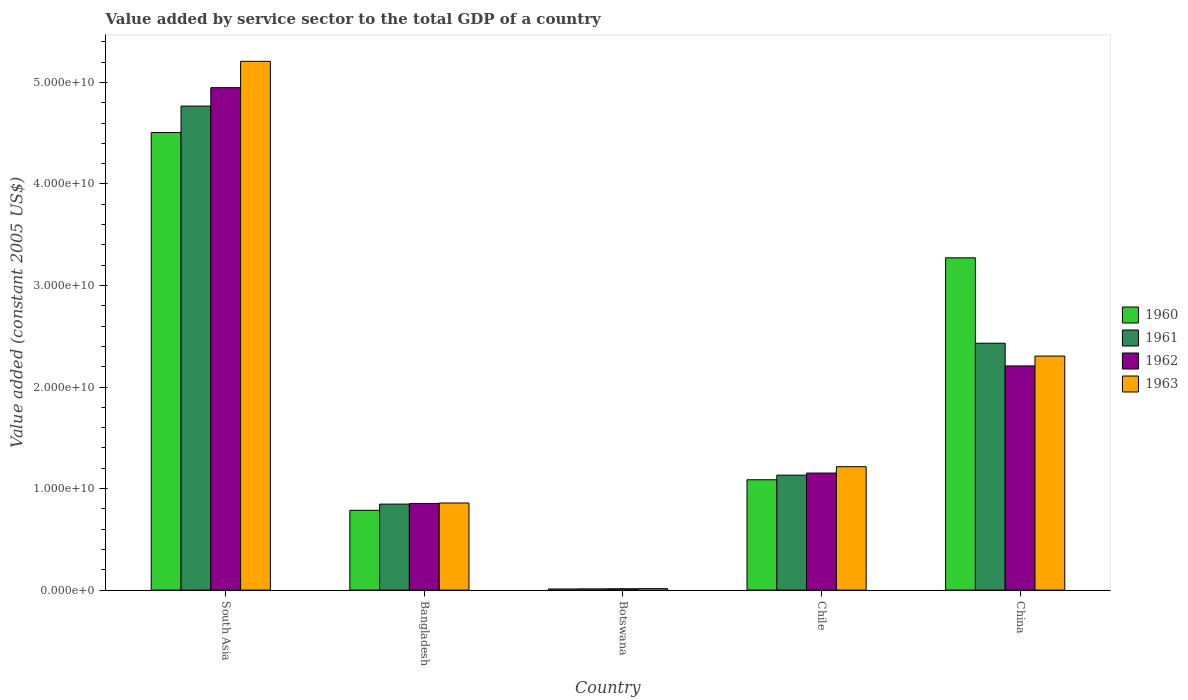Are the number of bars per tick equal to the number of legend labels?
Provide a short and direct response. Yes. Are the number of bars on each tick of the X-axis equal?
Your answer should be very brief. Yes. What is the label of the 2nd group of bars from the left?
Your answer should be very brief. Bangladesh. In how many cases, is the number of bars for a given country not equal to the number of legend labels?
Make the answer very short. 0. What is the value added by service sector in 1963 in Chile?
Your answer should be very brief. 1.22e+1. Across all countries, what is the maximum value added by service sector in 1961?
Your answer should be compact. 4.77e+1. Across all countries, what is the minimum value added by service sector in 1961?
Provide a short and direct response. 1.22e+08. In which country was the value added by service sector in 1962 minimum?
Your response must be concise. Botswana. What is the total value added by service sector in 1963 in the graph?
Offer a very short reply. 9.60e+1. What is the difference between the value added by service sector in 1961 in China and that in South Asia?
Provide a succinct answer. -2.34e+1. What is the difference between the value added by service sector in 1962 in Botswana and the value added by service sector in 1963 in Bangladesh?
Provide a short and direct response. -8.44e+09. What is the average value added by service sector in 1963 per country?
Ensure brevity in your answer.  1.92e+1. What is the difference between the value added by service sector of/in 1961 and value added by service sector of/in 1962 in Bangladesh?
Offer a terse response. -5.33e+07. What is the ratio of the value added by service sector in 1961 in Chile to that in China?
Offer a very short reply. 0.47. What is the difference between the highest and the second highest value added by service sector in 1960?
Your answer should be very brief. 1.23e+1. What is the difference between the highest and the lowest value added by service sector in 1963?
Your answer should be compact. 5.19e+1. In how many countries, is the value added by service sector in 1960 greater than the average value added by service sector in 1960 taken over all countries?
Provide a succinct answer. 2. Is it the case that in every country, the sum of the value added by service sector in 1961 and value added by service sector in 1963 is greater than the sum of value added by service sector in 1962 and value added by service sector in 1960?
Your answer should be very brief. No. Are all the bars in the graph horizontal?
Your answer should be very brief. No. What is the difference between two consecutive major ticks on the Y-axis?
Make the answer very short. 1.00e+1. Are the values on the major ticks of Y-axis written in scientific E-notation?
Ensure brevity in your answer.  Yes. Does the graph contain any zero values?
Your answer should be very brief. No. Does the graph contain grids?
Give a very brief answer. No. How many legend labels are there?
Your answer should be very brief. 4. How are the legend labels stacked?
Offer a very short reply. Vertical. What is the title of the graph?
Your answer should be compact. Value added by service sector to the total GDP of a country. What is the label or title of the Y-axis?
Offer a terse response. Value added (constant 2005 US$). What is the Value added (constant 2005 US$) in 1960 in South Asia?
Provide a succinct answer. 4.51e+1. What is the Value added (constant 2005 US$) of 1961 in South Asia?
Offer a very short reply. 4.77e+1. What is the Value added (constant 2005 US$) in 1962 in South Asia?
Provide a short and direct response. 4.95e+1. What is the Value added (constant 2005 US$) in 1963 in South Asia?
Your response must be concise. 5.21e+1. What is the Value added (constant 2005 US$) in 1960 in Bangladesh?
Offer a terse response. 7.86e+09. What is the Value added (constant 2005 US$) in 1961 in Bangladesh?
Give a very brief answer. 8.47e+09. What is the Value added (constant 2005 US$) of 1962 in Bangladesh?
Keep it short and to the point. 8.52e+09. What is the Value added (constant 2005 US$) of 1963 in Bangladesh?
Keep it short and to the point. 8.58e+09. What is the Value added (constant 2005 US$) of 1960 in Botswana?
Provide a succinct answer. 1.11e+08. What is the Value added (constant 2005 US$) in 1961 in Botswana?
Your response must be concise. 1.22e+08. What is the Value added (constant 2005 US$) of 1962 in Botswana?
Your answer should be very brief. 1.32e+08. What is the Value added (constant 2005 US$) in 1963 in Botswana?
Offer a very short reply. 1.45e+08. What is the Value added (constant 2005 US$) in 1960 in Chile?
Give a very brief answer. 1.09e+1. What is the Value added (constant 2005 US$) of 1961 in Chile?
Ensure brevity in your answer.  1.13e+1. What is the Value added (constant 2005 US$) of 1962 in Chile?
Ensure brevity in your answer.  1.15e+1. What is the Value added (constant 2005 US$) of 1963 in Chile?
Provide a short and direct response. 1.22e+1. What is the Value added (constant 2005 US$) in 1960 in China?
Offer a terse response. 3.27e+1. What is the Value added (constant 2005 US$) of 1961 in China?
Provide a succinct answer. 2.43e+1. What is the Value added (constant 2005 US$) of 1962 in China?
Provide a short and direct response. 2.21e+1. What is the Value added (constant 2005 US$) in 1963 in China?
Offer a terse response. 2.30e+1. Across all countries, what is the maximum Value added (constant 2005 US$) of 1960?
Your answer should be compact. 4.51e+1. Across all countries, what is the maximum Value added (constant 2005 US$) in 1961?
Make the answer very short. 4.77e+1. Across all countries, what is the maximum Value added (constant 2005 US$) of 1962?
Make the answer very short. 4.95e+1. Across all countries, what is the maximum Value added (constant 2005 US$) of 1963?
Provide a succinct answer. 5.21e+1. Across all countries, what is the minimum Value added (constant 2005 US$) of 1960?
Provide a succinct answer. 1.11e+08. Across all countries, what is the minimum Value added (constant 2005 US$) in 1961?
Provide a short and direct response. 1.22e+08. Across all countries, what is the minimum Value added (constant 2005 US$) of 1962?
Ensure brevity in your answer.  1.32e+08. Across all countries, what is the minimum Value added (constant 2005 US$) in 1963?
Provide a succinct answer. 1.45e+08. What is the total Value added (constant 2005 US$) in 1960 in the graph?
Keep it short and to the point. 9.66e+1. What is the total Value added (constant 2005 US$) of 1961 in the graph?
Offer a terse response. 9.19e+1. What is the total Value added (constant 2005 US$) of 1962 in the graph?
Your response must be concise. 9.17e+1. What is the total Value added (constant 2005 US$) of 1963 in the graph?
Provide a short and direct response. 9.60e+1. What is the difference between the Value added (constant 2005 US$) in 1960 in South Asia and that in Bangladesh?
Give a very brief answer. 3.72e+1. What is the difference between the Value added (constant 2005 US$) of 1961 in South Asia and that in Bangladesh?
Your response must be concise. 3.92e+1. What is the difference between the Value added (constant 2005 US$) in 1962 in South Asia and that in Bangladesh?
Provide a short and direct response. 4.10e+1. What is the difference between the Value added (constant 2005 US$) in 1963 in South Asia and that in Bangladesh?
Make the answer very short. 4.35e+1. What is the difference between the Value added (constant 2005 US$) of 1960 in South Asia and that in Botswana?
Provide a succinct answer. 4.50e+1. What is the difference between the Value added (constant 2005 US$) of 1961 in South Asia and that in Botswana?
Offer a very short reply. 4.75e+1. What is the difference between the Value added (constant 2005 US$) of 1962 in South Asia and that in Botswana?
Make the answer very short. 4.93e+1. What is the difference between the Value added (constant 2005 US$) in 1963 in South Asia and that in Botswana?
Offer a terse response. 5.19e+1. What is the difference between the Value added (constant 2005 US$) of 1960 in South Asia and that in Chile?
Your response must be concise. 3.42e+1. What is the difference between the Value added (constant 2005 US$) of 1961 in South Asia and that in Chile?
Keep it short and to the point. 3.63e+1. What is the difference between the Value added (constant 2005 US$) of 1962 in South Asia and that in Chile?
Provide a succinct answer. 3.80e+1. What is the difference between the Value added (constant 2005 US$) of 1963 in South Asia and that in Chile?
Keep it short and to the point. 3.99e+1. What is the difference between the Value added (constant 2005 US$) of 1960 in South Asia and that in China?
Your answer should be very brief. 1.23e+1. What is the difference between the Value added (constant 2005 US$) in 1961 in South Asia and that in China?
Provide a succinct answer. 2.34e+1. What is the difference between the Value added (constant 2005 US$) of 1962 in South Asia and that in China?
Make the answer very short. 2.74e+1. What is the difference between the Value added (constant 2005 US$) in 1963 in South Asia and that in China?
Keep it short and to the point. 2.90e+1. What is the difference between the Value added (constant 2005 US$) in 1960 in Bangladesh and that in Botswana?
Offer a terse response. 7.75e+09. What is the difference between the Value added (constant 2005 US$) of 1961 in Bangladesh and that in Botswana?
Make the answer very short. 8.35e+09. What is the difference between the Value added (constant 2005 US$) in 1962 in Bangladesh and that in Botswana?
Your answer should be compact. 8.39e+09. What is the difference between the Value added (constant 2005 US$) of 1963 in Bangladesh and that in Botswana?
Your answer should be very brief. 8.43e+09. What is the difference between the Value added (constant 2005 US$) in 1960 in Bangladesh and that in Chile?
Your answer should be compact. -3.01e+09. What is the difference between the Value added (constant 2005 US$) of 1961 in Bangladesh and that in Chile?
Make the answer very short. -2.85e+09. What is the difference between the Value added (constant 2005 US$) in 1962 in Bangladesh and that in Chile?
Make the answer very short. -3.00e+09. What is the difference between the Value added (constant 2005 US$) of 1963 in Bangladesh and that in Chile?
Your response must be concise. -3.58e+09. What is the difference between the Value added (constant 2005 US$) in 1960 in Bangladesh and that in China?
Keep it short and to the point. -2.49e+1. What is the difference between the Value added (constant 2005 US$) in 1961 in Bangladesh and that in China?
Offer a very short reply. -1.58e+1. What is the difference between the Value added (constant 2005 US$) in 1962 in Bangladesh and that in China?
Your answer should be compact. -1.36e+1. What is the difference between the Value added (constant 2005 US$) in 1963 in Bangladesh and that in China?
Offer a terse response. -1.45e+1. What is the difference between the Value added (constant 2005 US$) of 1960 in Botswana and that in Chile?
Your response must be concise. -1.08e+1. What is the difference between the Value added (constant 2005 US$) of 1961 in Botswana and that in Chile?
Ensure brevity in your answer.  -1.12e+1. What is the difference between the Value added (constant 2005 US$) in 1962 in Botswana and that in Chile?
Ensure brevity in your answer.  -1.14e+1. What is the difference between the Value added (constant 2005 US$) of 1963 in Botswana and that in Chile?
Give a very brief answer. -1.20e+1. What is the difference between the Value added (constant 2005 US$) of 1960 in Botswana and that in China?
Keep it short and to the point. -3.26e+1. What is the difference between the Value added (constant 2005 US$) of 1961 in Botswana and that in China?
Make the answer very short. -2.42e+1. What is the difference between the Value added (constant 2005 US$) of 1962 in Botswana and that in China?
Your response must be concise. -2.19e+1. What is the difference between the Value added (constant 2005 US$) of 1963 in Botswana and that in China?
Give a very brief answer. -2.29e+1. What is the difference between the Value added (constant 2005 US$) in 1960 in Chile and that in China?
Your answer should be very brief. -2.19e+1. What is the difference between the Value added (constant 2005 US$) in 1961 in Chile and that in China?
Your response must be concise. -1.30e+1. What is the difference between the Value added (constant 2005 US$) in 1962 in Chile and that in China?
Provide a short and direct response. -1.05e+1. What is the difference between the Value added (constant 2005 US$) in 1963 in Chile and that in China?
Your answer should be very brief. -1.09e+1. What is the difference between the Value added (constant 2005 US$) in 1960 in South Asia and the Value added (constant 2005 US$) in 1961 in Bangladesh?
Your answer should be very brief. 3.66e+1. What is the difference between the Value added (constant 2005 US$) of 1960 in South Asia and the Value added (constant 2005 US$) of 1962 in Bangladesh?
Ensure brevity in your answer.  3.65e+1. What is the difference between the Value added (constant 2005 US$) in 1960 in South Asia and the Value added (constant 2005 US$) in 1963 in Bangladesh?
Provide a short and direct response. 3.65e+1. What is the difference between the Value added (constant 2005 US$) of 1961 in South Asia and the Value added (constant 2005 US$) of 1962 in Bangladesh?
Provide a succinct answer. 3.91e+1. What is the difference between the Value added (constant 2005 US$) of 1961 in South Asia and the Value added (constant 2005 US$) of 1963 in Bangladesh?
Provide a short and direct response. 3.91e+1. What is the difference between the Value added (constant 2005 US$) of 1962 in South Asia and the Value added (constant 2005 US$) of 1963 in Bangladesh?
Keep it short and to the point. 4.09e+1. What is the difference between the Value added (constant 2005 US$) in 1960 in South Asia and the Value added (constant 2005 US$) in 1961 in Botswana?
Your answer should be very brief. 4.49e+1. What is the difference between the Value added (constant 2005 US$) in 1960 in South Asia and the Value added (constant 2005 US$) in 1962 in Botswana?
Your answer should be compact. 4.49e+1. What is the difference between the Value added (constant 2005 US$) of 1960 in South Asia and the Value added (constant 2005 US$) of 1963 in Botswana?
Offer a terse response. 4.49e+1. What is the difference between the Value added (constant 2005 US$) of 1961 in South Asia and the Value added (constant 2005 US$) of 1962 in Botswana?
Make the answer very short. 4.75e+1. What is the difference between the Value added (constant 2005 US$) of 1961 in South Asia and the Value added (constant 2005 US$) of 1963 in Botswana?
Offer a terse response. 4.75e+1. What is the difference between the Value added (constant 2005 US$) of 1962 in South Asia and the Value added (constant 2005 US$) of 1963 in Botswana?
Offer a terse response. 4.93e+1. What is the difference between the Value added (constant 2005 US$) of 1960 in South Asia and the Value added (constant 2005 US$) of 1961 in Chile?
Offer a very short reply. 3.37e+1. What is the difference between the Value added (constant 2005 US$) in 1960 in South Asia and the Value added (constant 2005 US$) in 1962 in Chile?
Your response must be concise. 3.35e+1. What is the difference between the Value added (constant 2005 US$) of 1960 in South Asia and the Value added (constant 2005 US$) of 1963 in Chile?
Your response must be concise. 3.29e+1. What is the difference between the Value added (constant 2005 US$) in 1961 in South Asia and the Value added (constant 2005 US$) in 1962 in Chile?
Make the answer very short. 3.61e+1. What is the difference between the Value added (constant 2005 US$) in 1961 in South Asia and the Value added (constant 2005 US$) in 1963 in Chile?
Keep it short and to the point. 3.55e+1. What is the difference between the Value added (constant 2005 US$) in 1962 in South Asia and the Value added (constant 2005 US$) in 1963 in Chile?
Your answer should be very brief. 3.73e+1. What is the difference between the Value added (constant 2005 US$) in 1960 in South Asia and the Value added (constant 2005 US$) in 1961 in China?
Keep it short and to the point. 2.08e+1. What is the difference between the Value added (constant 2005 US$) of 1960 in South Asia and the Value added (constant 2005 US$) of 1962 in China?
Give a very brief answer. 2.30e+1. What is the difference between the Value added (constant 2005 US$) in 1960 in South Asia and the Value added (constant 2005 US$) in 1963 in China?
Keep it short and to the point. 2.20e+1. What is the difference between the Value added (constant 2005 US$) of 1961 in South Asia and the Value added (constant 2005 US$) of 1962 in China?
Your answer should be very brief. 2.56e+1. What is the difference between the Value added (constant 2005 US$) in 1961 in South Asia and the Value added (constant 2005 US$) in 1963 in China?
Your response must be concise. 2.46e+1. What is the difference between the Value added (constant 2005 US$) of 1962 in South Asia and the Value added (constant 2005 US$) of 1963 in China?
Keep it short and to the point. 2.64e+1. What is the difference between the Value added (constant 2005 US$) in 1960 in Bangladesh and the Value added (constant 2005 US$) in 1961 in Botswana?
Make the answer very short. 7.74e+09. What is the difference between the Value added (constant 2005 US$) in 1960 in Bangladesh and the Value added (constant 2005 US$) in 1962 in Botswana?
Offer a terse response. 7.73e+09. What is the difference between the Value added (constant 2005 US$) of 1960 in Bangladesh and the Value added (constant 2005 US$) of 1963 in Botswana?
Provide a short and direct response. 7.72e+09. What is the difference between the Value added (constant 2005 US$) of 1961 in Bangladesh and the Value added (constant 2005 US$) of 1962 in Botswana?
Ensure brevity in your answer.  8.34e+09. What is the difference between the Value added (constant 2005 US$) in 1961 in Bangladesh and the Value added (constant 2005 US$) in 1963 in Botswana?
Provide a short and direct response. 8.32e+09. What is the difference between the Value added (constant 2005 US$) of 1962 in Bangladesh and the Value added (constant 2005 US$) of 1963 in Botswana?
Keep it short and to the point. 8.38e+09. What is the difference between the Value added (constant 2005 US$) in 1960 in Bangladesh and the Value added (constant 2005 US$) in 1961 in Chile?
Keep it short and to the point. -3.46e+09. What is the difference between the Value added (constant 2005 US$) of 1960 in Bangladesh and the Value added (constant 2005 US$) of 1962 in Chile?
Keep it short and to the point. -3.67e+09. What is the difference between the Value added (constant 2005 US$) in 1960 in Bangladesh and the Value added (constant 2005 US$) in 1963 in Chile?
Offer a terse response. -4.29e+09. What is the difference between the Value added (constant 2005 US$) of 1961 in Bangladesh and the Value added (constant 2005 US$) of 1962 in Chile?
Provide a succinct answer. -3.06e+09. What is the difference between the Value added (constant 2005 US$) in 1961 in Bangladesh and the Value added (constant 2005 US$) in 1963 in Chile?
Your response must be concise. -3.68e+09. What is the difference between the Value added (constant 2005 US$) of 1962 in Bangladesh and the Value added (constant 2005 US$) of 1963 in Chile?
Make the answer very short. -3.63e+09. What is the difference between the Value added (constant 2005 US$) in 1960 in Bangladesh and the Value added (constant 2005 US$) in 1961 in China?
Give a very brief answer. -1.65e+1. What is the difference between the Value added (constant 2005 US$) of 1960 in Bangladesh and the Value added (constant 2005 US$) of 1962 in China?
Offer a very short reply. -1.42e+1. What is the difference between the Value added (constant 2005 US$) in 1960 in Bangladesh and the Value added (constant 2005 US$) in 1963 in China?
Keep it short and to the point. -1.52e+1. What is the difference between the Value added (constant 2005 US$) in 1961 in Bangladesh and the Value added (constant 2005 US$) in 1962 in China?
Your answer should be very brief. -1.36e+1. What is the difference between the Value added (constant 2005 US$) in 1961 in Bangladesh and the Value added (constant 2005 US$) in 1963 in China?
Your response must be concise. -1.46e+1. What is the difference between the Value added (constant 2005 US$) of 1962 in Bangladesh and the Value added (constant 2005 US$) of 1963 in China?
Ensure brevity in your answer.  -1.45e+1. What is the difference between the Value added (constant 2005 US$) in 1960 in Botswana and the Value added (constant 2005 US$) in 1961 in Chile?
Provide a short and direct response. -1.12e+1. What is the difference between the Value added (constant 2005 US$) of 1960 in Botswana and the Value added (constant 2005 US$) of 1962 in Chile?
Provide a short and direct response. -1.14e+1. What is the difference between the Value added (constant 2005 US$) of 1960 in Botswana and the Value added (constant 2005 US$) of 1963 in Chile?
Provide a short and direct response. -1.20e+1. What is the difference between the Value added (constant 2005 US$) in 1961 in Botswana and the Value added (constant 2005 US$) in 1962 in Chile?
Your answer should be very brief. -1.14e+1. What is the difference between the Value added (constant 2005 US$) in 1961 in Botswana and the Value added (constant 2005 US$) in 1963 in Chile?
Provide a short and direct response. -1.20e+1. What is the difference between the Value added (constant 2005 US$) of 1962 in Botswana and the Value added (constant 2005 US$) of 1963 in Chile?
Ensure brevity in your answer.  -1.20e+1. What is the difference between the Value added (constant 2005 US$) of 1960 in Botswana and the Value added (constant 2005 US$) of 1961 in China?
Offer a terse response. -2.42e+1. What is the difference between the Value added (constant 2005 US$) in 1960 in Botswana and the Value added (constant 2005 US$) in 1962 in China?
Offer a terse response. -2.20e+1. What is the difference between the Value added (constant 2005 US$) of 1960 in Botswana and the Value added (constant 2005 US$) of 1963 in China?
Provide a succinct answer. -2.29e+1. What is the difference between the Value added (constant 2005 US$) of 1961 in Botswana and the Value added (constant 2005 US$) of 1962 in China?
Your response must be concise. -2.20e+1. What is the difference between the Value added (constant 2005 US$) of 1961 in Botswana and the Value added (constant 2005 US$) of 1963 in China?
Provide a short and direct response. -2.29e+1. What is the difference between the Value added (constant 2005 US$) in 1962 in Botswana and the Value added (constant 2005 US$) in 1963 in China?
Offer a very short reply. -2.29e+1. What is the difference between the Value added (constant 2005 US$) of 1960 in Chile and the Value added (constant 2005 US$) of 1961 in China?
Ensure brevity in your answer.  -1.34e+1. What is the difference between the Value added (constant 2005 US$) in 1960 in Chile and the Value added (constant 2005 US$) in 1962 in China?
Your answer should be compact. -1.12e+1. What is the difference between the Value added (constant 2005 US$) of 1960 in Chile and the Value added (constant 2005 US$) of 1963 in China?
Provide a succinct answer. -1.22e+1. What is the difference between the Value added (constant 2005 US$) in 1961 in Chile and the Value added (constant 2005 US$) in 1962 in China?
Your answer should be very brief. -1.08e+1. What is the difference between the Value added (constant 2005 US$) of 1961 in Chile and the Value added (constant 2005 US$) of 1963 in China?
Provide a short and direct response. -1.17e+1. What is the difference between the Value added (constant 2005 US$) in 1962 in Chile and the Value added (constant 2005 US$) in 1963 in China?
Your answer should be compact. -1.15e+1. What is the average Value added (constant 2005 US$) in 1960 per country?
Keep it short and to the point. 1.93e+1. What is the average Value added (constant 2005 US$) in 1961 per country?
Your answer should be compact. 1.84e+1. What is the average Value added (constant 2005 US$) of 1962 per country?
Provide a succinct answer. 1.83e+1. What is the average Value added (constant 2005 US$) of 1963 per country?
Your answer should be compact. 1.92e+1. What is the difference between the Value added (constant 2005 US$) of 1960 and Value added (constant 2005 US$) of 1961 in South Asia?
Provide a succinct answer. -2.61e+09. What is the difference between the Value added (constant 2005 US$) of 1960 and Value added (constant 2005 US$) of 1962 in South Asia?
Provide a succinct answer. -4.42e+09. What is the difference between the Value added (constant 2005 US$) in 1960 and Value added (constant 2005 US$) in 1963 in South Asia?
Make the answer very short. -7.01e+09. What is the difference between the Value added (constant 2005 US$) of 1961 and Value added (constant 2005 US$) of 1962 in South Asia?
Make the answer very short. -1.81e+09. What is the difference between the Value added (constant 2005 US$) in 1961 and Value added (constant 2005 US$) in 1963 in South Asia?
Make the answer very short. -4.41e+09. What is the difference between the Value added (constant 2005 US$) in 1962 and Value added (constant 2005 US$) in 1963 in South Asia?
Offer a terse response. -2.59e+09. What is the difference between the Value added (constant 2005 US$) in 1960 and Value added (constant 2005 US$) in 1961 in Bangladesh?
Give a very brief answer. -6.09e+08. What is the difference between the Value added (constant 2005 US$) of 1960 and Value added (constant 2005 US$) of 1962 in Bangladesh?
Make the answer very short. -6.62e+08. What is the difference between the Value added (constant 2005 US$) in 1960 and Value added (constant 2005 US$) in 1963 in Bangladesh?
Provide a succinct answer. -7.16e+08. What is the difference between the Value added (constant 2005 US$) in 1961 and Value added (constant 2005 US$) in 1962 in Bangladesh?
Keep it short and to the point. -5.33e+07. What is the difference between the Value added (constant 2005 US$) in 1961 and Value added (constant 2005 US$) in 1963 in Bangladesh?
Make the answer very short. -1.08e+08. What is the difference between the Value added (constant 2005 US$) of 1962 and Value added (constant 2005 US$) of 1963 in Bangladesh?
Make the answer very short. -5.45e+07. What is the difference between the Value added (constant 2005 US$) of 1960 and Value added (constant 2005 US$) of 1961 in Botswana?
Make the answer very short. -1.12e+07. What is the difference between the Value added (constant 2005 US$) in 1960 and Value added (constant 2005 US$) in 1962 in Botswana?
Your answer should be compact. -2.17e+07. What is the difference between the Value added (constant 2005 US$) in 1960 and Value added (constant 2005 US$) in 1963 in Botswana?
Provide a succinct answer. -3.45e+07. What is the difference between the Value added (constant 2005 US$) in 1961 and Value added (constant 2005 US$) in 1962 in Botswana?
Offer a very short reply. -1.05e+07. What is the difference between the Value added (constant 2005 US$) of 1961 and Value added (constant 2005 US$) of 1963 in Botswana?
Provide a succinct answer. -2.33e+07. What is the difference between the Value added (constant 2005 US$) of 1962 and Value added (constant 2005 US$) of 1963 in Botswana?
Provide a succinct answer. -1.28e+07. What is the difference between the Value added (constant 2005 US$) in 1960 and Value added (constant 2005 US$) in 1961 in Chile?
Offer a very short reply. -4.53e+08. What is the difference between the Value added (constant 2005 US$) of 1960 and Value added (constant 2005 US$) of 1962 in Chile?
Your answer should be very brief. -6.60e+08. What is the difference between the Value added (constant 2005 US$) in 1960 and Value added (constant 2005 US$) in 1963 in Chile?
Provide a succinct answer. -1.29e+09. What is the difference between the Value added (constant 2005 US$) in 1961 and Value added (constant 2005 US$) in 1962 in Chile?
Give a very brief answer. -2.07e+08. What is the difference between the Value added (constant 2005 US$) of 1961 and Value added (constant 2005 US$) of 1963 in Chile?
Your answer should be compact. -8.32e+08. What is the difference between the Value added (constant 2005 US$) of 1962 and Value added (constant 2005 US$) of 1963 in Chile?
Give a very brief answer. -6.25e+08. What is the difference between the Value added (constant 2005 US$) of 1960 and Value added (constant 2005 US$) of 1961 in China?
Make the answer very short. 8.41e+09. What is the difference between the Value added (constant 2005 US$) in 1960 and Value added (constant 2005 US$) in 1962 in China?
Provide a short and direct response. 1.06e+1. What is the difference between the Value added (constant 2005 US$) in 1960 and Value added (constant 2005 US$) in 1963 in China?
Provide a short and direct response. 9.68e+09. What is the difference between the Value added (constant 2005 US$) in 1961 and Value added (constant 2005 US$) in 1962 in China?
Your response must be concise. 2.24e+09. What is the difference between the Value added (constant 2005 US$) of 1961 and Value added (constant 2005 US$) of 1963 in China?
Give a very brief answer. 1.27e+09. What is the difference between the Value added (constant 2005 US$) in 1962 and Value added (constant 2005 US$) in 1963 in China?
Keep it short and to the point. -9.71e+08. What is the ratio of the Value added (constant 2005 US$) of 1960 in South Asia to that in Bangladesh?
Give a very brief answer. 5.73. What is the ratio of the Value added (constant 2005 US$) of 1961 in South Asia to that in Bangladesh?
Ensure brevity in your answer.  5.63. What is the ratio of the Value added (constant 2005 US$) of 1962 in South Asia to that in Bangladesh?
Your answer should be compact. 5.81. What is the ratio of the Value added (constant 2005 US$) in 1963 in South Asia to that in Bangladesh?
Offer a very short reply. 6.07. What is the ratio of the Value added (constant 2005 US$) of 1960 in South Asia to that in Botswana?
Ensure brevity in your answer.  407.52. What is the ratio of the Value added (constant 2005 US$) of 1961 in South Asia to that in Botswana?
Offer a very short reply. 391.45. What is the ratio of the Value added (constant 2005 US$) of 1962 in South Asia to that in Botswana?
Your response must be concise. 374.08. What is the ratio of the Value added (constant 2005 US$) in 1963 in South Asia to that in Botswana?
Ensure brevity in your answer.  358.96. What is the ratio of the Value added (constant 2005 US$) in 1960 in South Asia to that in Chile?
Ensure brevity in your answer.  4.15. What is the ratio of the Value added (constant 2005 US$) of 1961 in South Asia to that in Chile?
Provide a succinct answer. 4.21. What is the ratio of the Value added (constant 2005 US$) of 1962 in South Asia to that in Chile?
Offer a very short reply. 4.29. What is the ratio of the Value added (constant 2005 US$) in 1963 in South Asia to that in Chile?
Your answer should be very brief. 4.29. What is the ratio of the Value added (constant 2005 US$) in 1960 in South Asia to that in China?
Your response must be concise. 1.38. What is the ratio of the Value added (constant 2005 US$) of 1961 in South Asia to that in China?
Keep it short and to the point. 1.96. What is the ratio of the Value added (constant 2005 US$) of 1962 in South Asia to that in China?
Keep it short and to the point. 2.24. What is the ratio of the Value added (constant 2005 US$) of 1963 in South Asia to that in China?
Your answer should be very brief. 2.26. What is the ratio of the Value added (constant 2005 US$) of 1960 in Bangladesh to that in Botswana?
Ensure brevity in your answer.  71.09. What is the ratio of the Value added (constant 2005 US$) of 1961 in Bangladesh to that in Botswana?
Your answer should be compact. 69.55. What is the ratio of the Value added (constant 2005 US$) of 1962 in Bangladesh to that in Botswana?
Make the answer very short. 64.43. What is the ratio of the Value added (constant 2005 US$) in 1963 in Bangladesh to that in Botswana?
Your answer should be compact. 59.12. What is the ratio of the Value added (constant 2005 US$) of 1960 in Bangladesh to that in Chile?
Your response must be concise. 0.72. What is the ratio of the Value added (constant 2005 US$) in 1961 in Bangladesh to that in Chile?
Ensure brevity in your answer.  0.75. What is the ratio of the Value added (constant 2005 US$) in 1962 in Bangladesh to that in Chile?
Your response must be concise. 0.74. What is the ratio of the Value added (constant 2005 US$) of 1963 in Bangladesh to that in Chile?
Your response must be concise. 0.71. What is the ratio of the Value added (constant 2005 US$) in 1960 in Bangladesh to that in China?
Make the answer very short. 0.24. What is the ratio of the Value added (constant 2005 US$) in 1961 in Bangladesh to that in China?
Offer a terse response. 0.35. What is the ratio of the Value added (constant 2005 US$) in 1962 in Bangladesh to that in China?
Make the answer very short. 0.39. What is the ratio of the Value added (constant 2005 US$) of 1963 in Bangladesh to that in China?
Offer a terse response. 0.37. What is the ratio of the Value added (constant 2005 US$) in 1960 in Botswana to that in Chile?
Keep it short and to the point. 0.01. What is the ratio of the Value added (constant 2005 US$) in 1961 in Botswana to that in Chile?
Offer a terse response. 0.01. What is the ratio of the Value added (constant 2005 US$) in 1962 in Botswana to that in Chile?
Make the answer very short. 0.01. What is the ratio of the Value added (constant 2005 US$) in 1963 in Botswana to that in Chile?
Your answer should be very brief. 0.01. What is the ratio of the Value added (constant 2005 US$) in 1960 in Botswana to that in China?
Give a very brief answer. 0. What is the ratio of the Value added (constant 2005 US$) of 1961 in Botswana to that in China?
Provide a succinct answer. 0.01. What is the ratio of the Value added (constant 2005 US$) in 1962 in Botswana to that in China?
Provide a short and direct response. 0.01. What is the ratio of the Value added (constant 2005 US$) of 1963 in Botswana to that in China?
Provide a succinct answer. 0.01. What is the ratio of the Value added (constant 2005 US$) of 1960 in Chile to that in China?
Your answer should be compact. 0.33. What is the ratio of the Value added (constant 2005 US$) in 1961 in Chile to that in China?
Keep it short and to the point. 0.47. What is the ratio of the Value added (constant 2005 US$) of 1962 in Chile to that in China?
Your answer should be very brief. 0.52. What is the ratio of the Value added (constant 2005 US$) in 1963 in Chile to that in China?
Your response must be concise. 0.53. What is the difference between the highest and the second highest Value added (constant 2005 US$) in 1960?
Keep it short and to the point. 1.23e+1. What is the difference between the highest and the second highest Value added (constant 2005 US$) in 1961?
Keep it short and to the point. 2.34e+1. What is the difference between the highest and the second highest Value added (constant 2005 US$) of 1962?
Your answer should be very brief. 2.74e+1. What is the difference between the highest and the second highest Value added (constant 2005 US$) of 1963?
Give a very brief answer. 2.90e+1. What is the difference between the highest and the lowest Value added (constant 2005 US$) of 1960?
Ensure brevity in your answer.  4.50e+1. What is the difference between the highest and the lowest Value added (constant 2005 US$) in 1961?
Offer a very short reply. 4.75e+1. What is the difference between the highest and the lowest Value added (constant 2005 US$) of 1962?
Ensure brevity in your answer.  4.93e+1. What is the difference between the highest and the lowest Value added (constant 2005 US$) of 1963?
Make the answer very short. 5.19e+1. 